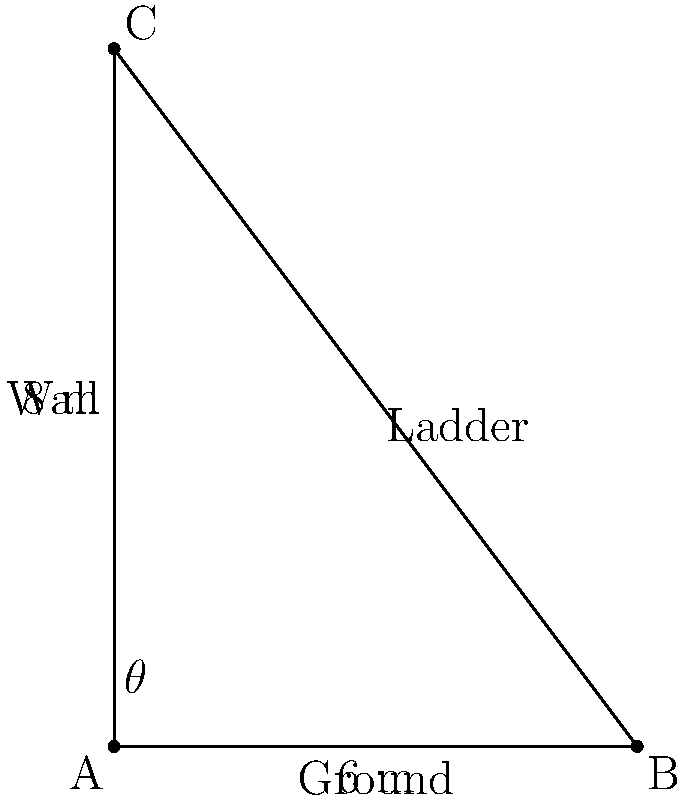As you're setting up a new display in your bookstore, you need to use a ladder to reach the top shelf. The ladder is leaning against the wall, with its base 6 meters from the wall and its top reaching a height of 8 meters. What is the angle of inclination ($\theta$) between the ladder and the ground? To solve this problem, we can use trigonometry, specifically the arctangent function. Let's approach this step-by-step:

1) We have a right triangle formed by the ladder, the wall, and the ground.
2) The base of the triangle (distance from the wall to the ladder's base) is 6 meters.
3) The height of the triangle (height reached by the ladder) is 8 meters.
4) We need to find the angle $\theta$ between the ladder and the ground.

5) In a right triangle, tangent of an angle is the ratio of the opposite side to the adjacent side:

   $\tan(\theta) = \frac{\text{opposite}}{\text{adjacent}} = \frac{\text{height}}{\text{base}} = \frac{8}{6}$

6) To find $\theta$, we need to use the inverse tangent (arctangent) function:

   $\theta = \arctan(\frac{8}{6})$

7) Simplifying the fraction:
   
   $\theta = \arctan(\frac{4}{3})$

8) Using a calculator or trigonometric tables:

   $\theta \approx 53.13^\circ$

Therefore, the angle of inclination of the ladder is approximately 53.13 degrees.
Answer: $53.13^\circ$ 